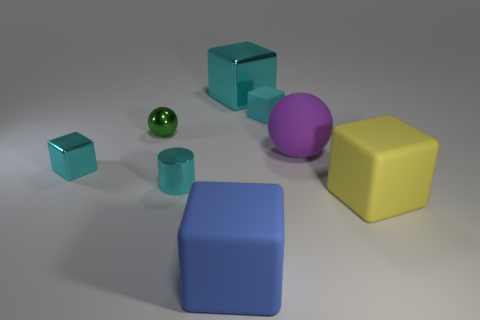Subtract all cyan cubes. How many were subtracted if there are1cyan cubes left? 2 Subtract all green cylinders. How many cyan cubes are left? 3 Subtract 2 blocks. How many blocks are left? 3 Subtract all blue cubes. How many cubes are left? 4 Subtract all yellow blocks. How many blocks are left? 4 Subtract all green cubes. Subtract all gray balls. How many cubes are left? 5 Add 1 yellow matte blocks. How many objects exist? 9 Subtract all cubes. How many objects are left? 3 Subtract all red objects. Subtract all large blocks. How many objects are left? 5 Add 7 purple rubber things. How many purple rubber things are left? 8 